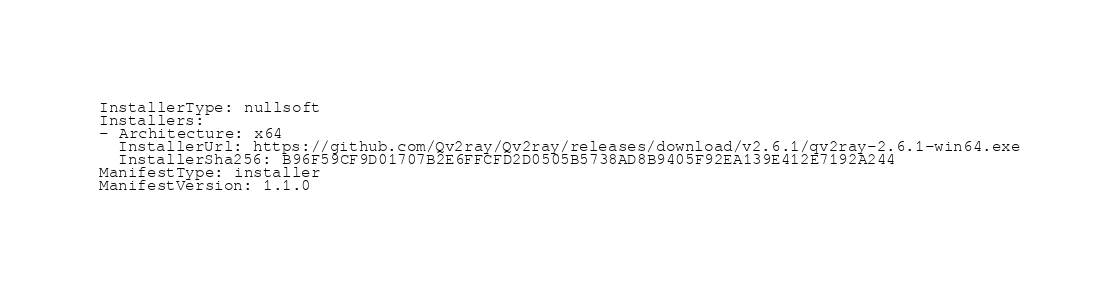<code> <loc_0><loc_0><loc_500><loc_500><_YAML_>InstallerType: nullsoft
Installers:
- Architecture: x64
  InstallerUrl: https://github.com/Qv2ray/Qv2ray/releases/download/v2.6.1/qv2ray-2.6.1-win64.exe
  InstallerSha256: B96F59CF9D01707B2E6FFCFD2D0505B5738AD8B9405F92EA139E412E7192A244
ManifestType: installer
ManifestVersion: 1.1.0
</code> 